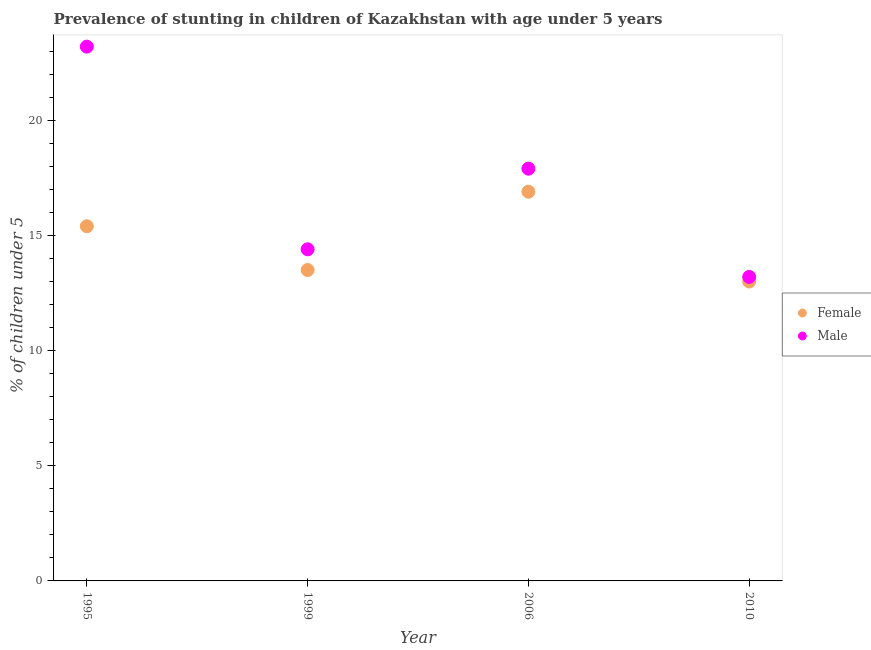What is the percentage of stunted female children in 2006?
Your answer should be compact. 16.9. Across all years, what is the maximum percentage of stunted female children?
Make the answer very short. 16.9. In which year was the percentage of stunted female children maximum?
Keep it short and to the point. 2006. In which year was the percentage of stunted male children minimum?
Offer a terse response. 2010. What is the total percentage of stunted female children in the graph?
Your response must be concise. 58.8. What is the difference between the percentage of stunted female children in 2010 and the percentage of stunted male children in 1999?
Your answer should be compact. -1.4. What is the average percentage of stunted male children per year?
Your answer should be compact. 17.17. In the year 2010, what is the difference between the percentage of stunted female children and percentage of stunted male children?
Offer a very short reply. -0.2. In how many years, is the percentage of stunted female children greater than 1 %?
Provide a short and direct response. 4. What is the ratio of the percentage of stunted male children in 1995 to that in 2010?
Give a very brief answer. 1.76. Is the difference between the percentage of stunted male children in 1995 and 1999 greater than the difference between the percentage of stunted female children in 1995 and 1999?
Give a very brief answer. Yes. What is the difference between the highest and the second highest percentage of stunted male children?
Offer a terse response. 5.3. What is the difference between the highest and the lowest percentage of stunted male children?
Your response must be concise. 10. In how many years, is the percentage of stunted male children greater than the average percentage of stunted male children taken over all years?
Your answer should be compact. 2. Does the percentage of stunted female children monotonically increase over the years?
Your answer should be compact. No. What is the difference between two consecutive major ticks on the Y-axis?
Give a very brief answer. 5. Does the graph contain any zero values?
Offer a terse response. No. Does the graph contain grids?
Offer a very short reply. No. Where does the legend appear in the graph?
Offer a very short reply. Center right. How are the legend labels stacked?
Keep it short and to the point. Vertical. What is the title of the graph?
Provide a short and direct response. Prevalence of stunting in children of Kazakhstan with age under 5 years. Does "Travel Items" appear as one of the legend labels in the graph?
Your answer should be compact. No. What is the label or title of the X-axis?
Your answer should be very brief. Year. What is the label or title of the Y-axis?
Make the answer very short.  % of children under 5. What is the  % of children under 5 in Female in 1995?
Offer a very short reply. 15.4. What is the  % of children under 5 of Male in 1995?
Make the answer very short. 23.2. What is the  % of children under 5 of Male in 1999?
Your response must be concise. 14.4. What is the  % of children under 5 in Female in 2006?
Your answer should be compact. 16.9. What is the  % of children under 5 of Male in 2006?
Provide a succinct answer. 17.9. What is the  % of children under 5 of Female in 2010?
Make the answer very short. 13. What is the  % of children under 5 of Male in 2010?
Give a very brief answer. 13.2. Across all years, what is the maximum  % of children under 5 in Female?
Give a very brief answer. 16.9. Across all years, what is the maximum  % of children under 5 of Male?
Your answer should be compact. 23.2. Across all years, what is the minimum  % of children under 5 in Female?
Keep it short and to the point. 13. Across all years, what is the minimum  % of children under 5 of Male?
Ensure brevity in your answer.  13.2. What is the total  % of children under 5 in Female in the graph?
Provide a succinct answer. 58.8. What is the total  % of children under 5 of Male in the graph?
Your answer should be very brief. 68.7. What is the difference between the  % of children under 5 of Female in 1995 and that in 1999?
Offer a very short reply. 1.9. What is the difference between the  % of children under 5 in Male in 1995 and that in 1999?
Give a very brief answer. 8.8. What is the difference between the  % of children under 5 of Female in 1995 and that in 2010?
Your response must be concise. 2.4. What is the difference between the  % of children under 5 in Male in 1995 and that in 2010?
Offer a terse response. 10. What is the difference between the  % of children under 5 of Female in 1999 and that in 2006?
Your response must be concise. -3.4. What is the difference between the  % of children under 5 in Female in 1999 and that in 2010?
Keep it short and to the point. 0.5. What is the difference between the  % of children under 5 of Male in 1999 and that in 2010?
Keep it short and to the point. 1.2. What is the difference between the  % of children under 5 in Female in 1999 and the  % of children under 5 in Male in 2006?
Provide a short and direct response. -4.4. What is the difference between the  % of children under 5 in Female in 1999 and the  % of children under 5 in Male in 2010?
Your answer should be very brief. 0.3. What is the difference between the  % of children under 5 of Female in 2006 and the  % of children under 5 of Male in 2010?
Provide a succinct answer. 3.7. What is the average  % of children under 5 in Female per year?
Ensure brevity in your answer.  14.7. What is the average  % of children under 5 in Male per year?
Provide a short and direct response. 17.18. In the year 1999, what is the difference between the  % of children under 5 of Female and  % of children under 5 of Male?
Offer a terse response. -0.9. In the year 2006, what is the difference between the  % of children under 5 in Female and  % of children under 5 in Male?
Ensure brevity in your answer.  -1. In the year 2010, what is the difference between the  % of children under 5 in Female and  % of children under 5 in Male?
Ensure brevity in your answer.  -0.2. What is the ratio of the  % of children under 5 of Female in 1995 to that in 1999?
Offer a very short reply. 1.14. What is the ratio of the  % of children under 5 in Male in 1995 to that in 1999?
Offer a very short reply. 1.61. What is the ratio of the  % of children under 5 in Female in 1995 to that in 2006?
Your answer should be very brief. 0.91. What is the ratio of the  % of children under 5 in Male in 1995 to that in 2006?
Your response must be concise. 1.3. What is the ratio of the  % of children under 5 of Female in 1995 to that in 2010?
Offer a very short reply. 1.18. What is the ratio of the  % of children under 5 in Male in 1995 to that in 2010?
Offer a terse response. 1.76. What is the ratio of the  % of children under 5 in Female in 1999 to that in 2006?
Provide a succinct answer. 0.8. What is the ratio of the  % of children under 5 in Male in 1999 to that in 2006?
Your answer should be compact. 0.8. What is the ratio of the  % of children under 5 of Male in 1999 to that in 2010?
Keep it short and to the point. 1.09. What is the ratio of the  % of children under 5 of Male in 2006 to that in 2010?
Offer a terse response. 1.36. 